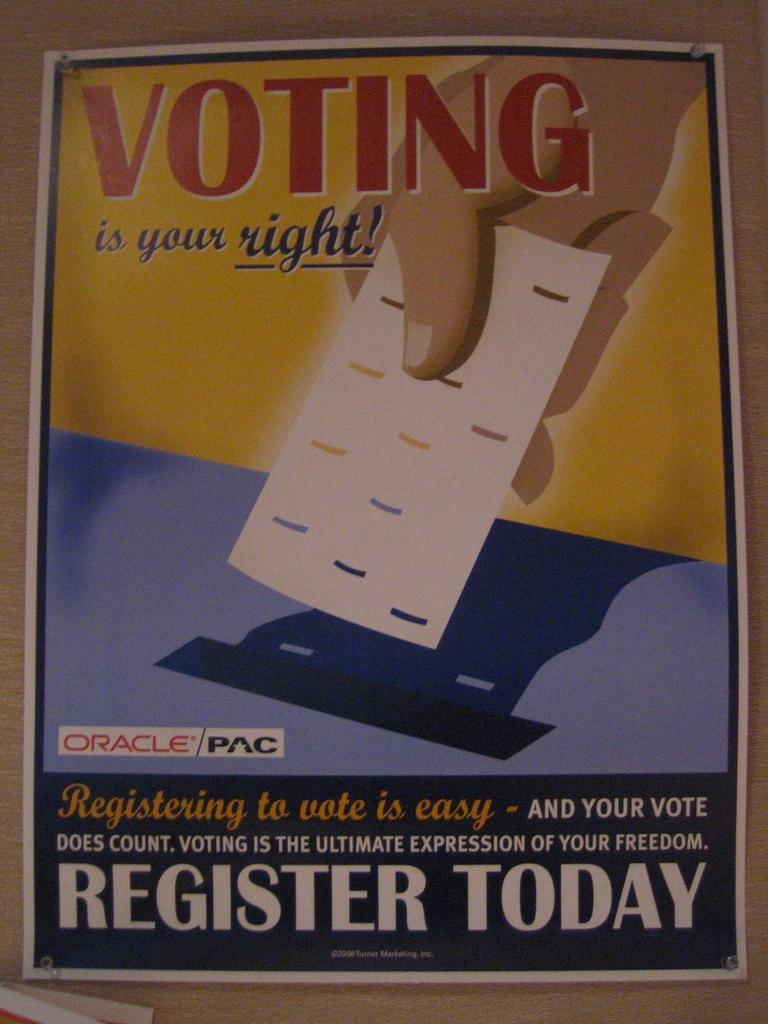<image>
Describe the image concisely. An advertising poster encouraging people to Register to vote. 